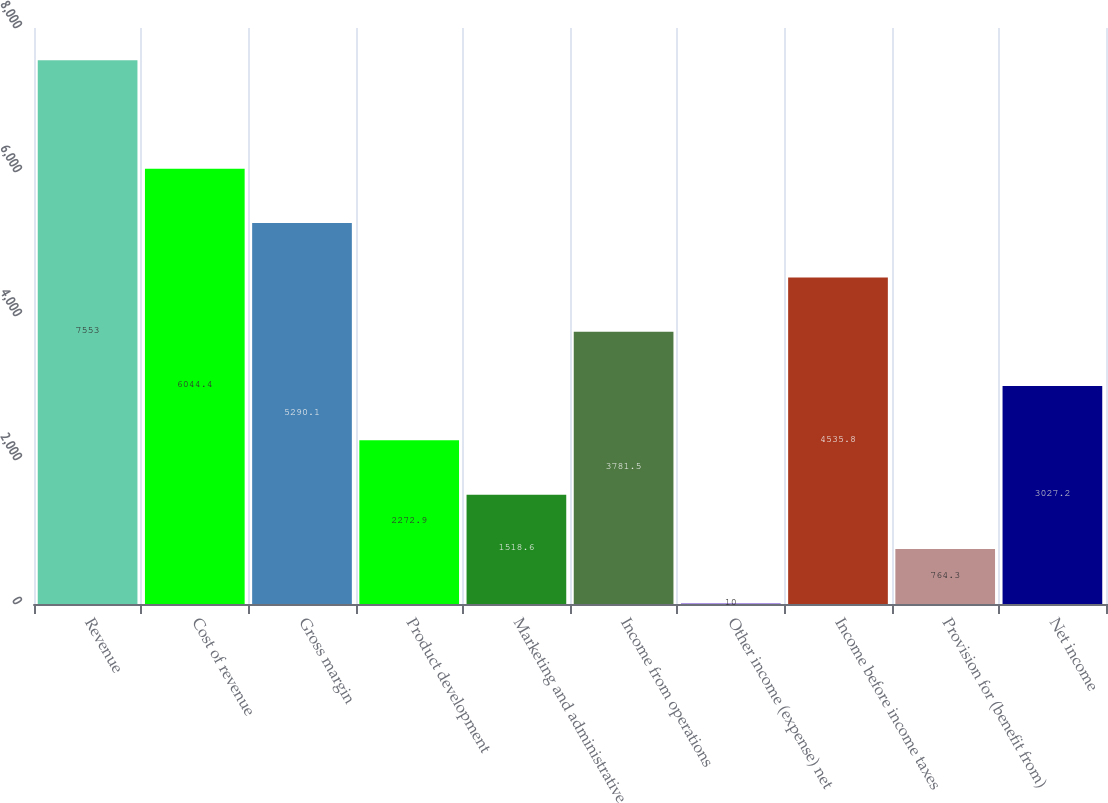Convert chart to OTSL. <chart><loc_0><loc_0><loc_500><loc_500><bar_chart><fcel>Revenue<fcel>Cost of revenue<fcel>Gross margin<fcel>Product development<fcel>Marketing and administrative<fcel>Income from operations<fcel>Other income (expense) net<fcel>Income before income taxes<fcel>Provision for (benefit from)<fcel>Net income<nl><fcel>7553<fcel>6044.4<fcel>5290.1<fcel>2272.9<fcel>1518.6<fcel>3781.5<fcel>10<fcel>4535.8<fcel>764.3<fcel>3027.2<nl></chart> 